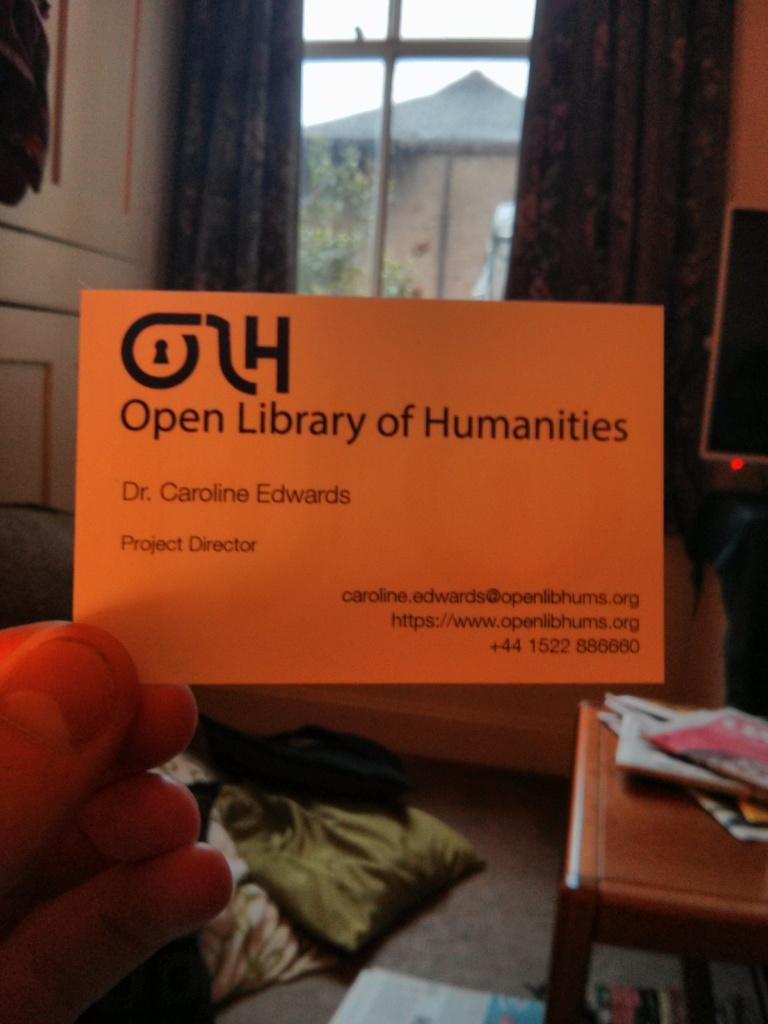<image>
Write a terse but informative summary of the picture. A person holds up a business card for Open Library of Humanities. 